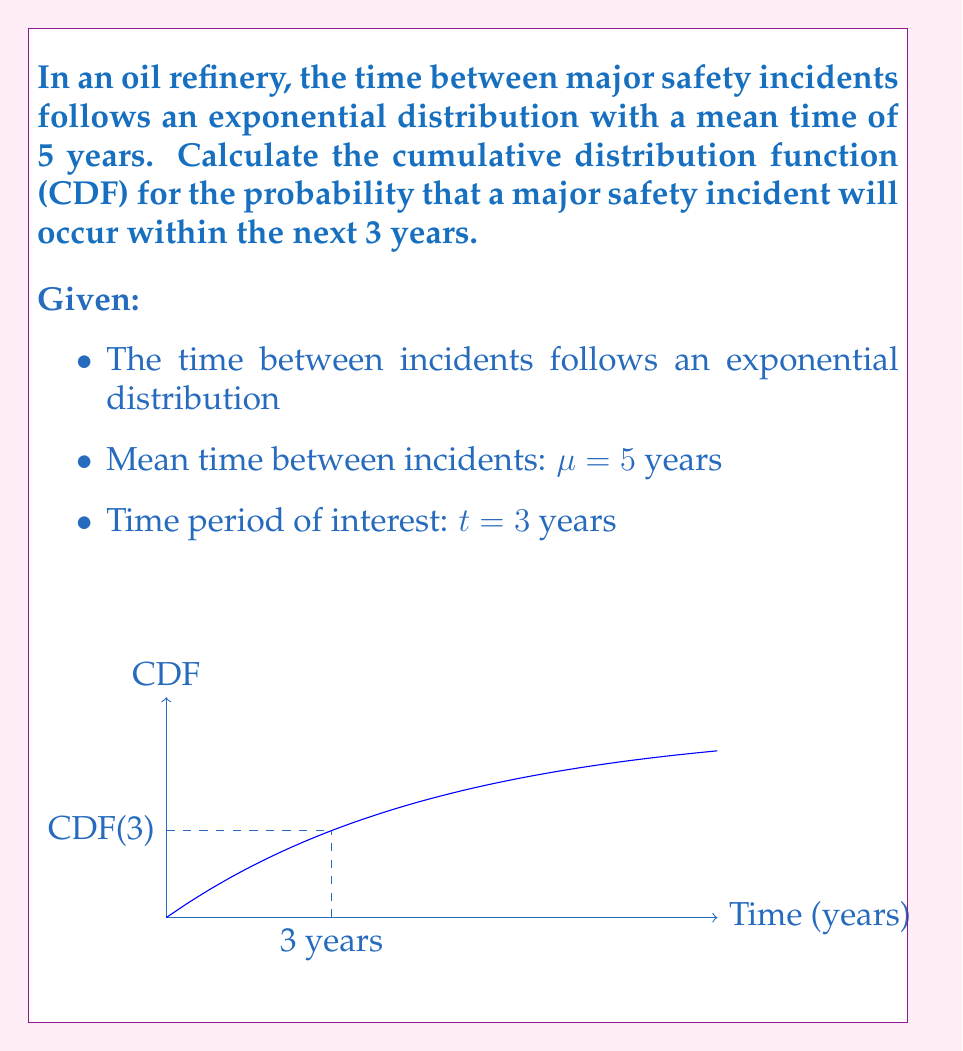Teach me how to tackle this problem. Let's approach this step-by-step:

1) For an exponential distribution, the probability density function (PDF) is given by:

   $$f(t) = \lambda e^{-\lambda t}$$

   where $\lambda$ is the rate parameter.

2) The rate parameter $\lambda$ is the inverse of the mean:

   $$\lambda = \frac{1}{\mu} = \frac{1}{5} = 0.2$$

3) The cumulative distribution function (CDF) for an exponential distribution is:

   $$F(t) = 1 - e^{-\lambda t}$$

4) Substituting our values:

   $$F(3) = 1 - e^{-0.2 \cdot 3}$$

5) Calculating:

   $$F(3) = 1 - e^{-0.6}$$
   $$F(3) = 1 - 0.5488$$
   $$F(3) \approx 0.4512$$

6) Therefore, the probability that a major safety incident will occur within the next 3 years is approximately 0.4512 or 45.12%.
Answer: $F(3) = 1 - e^{-0.6} \approx 0.4512$ 